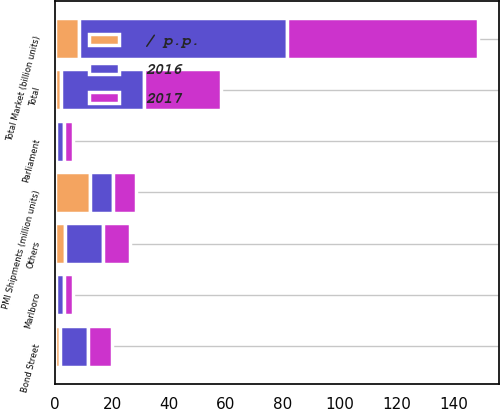<chart> <loc_0><loc_0><loc_500><loc_500><stacked_bar_chart><ecel><fcel>Total Market (billion units)<fcel>PMI Shipments (million units)<fcel>Marlboro<fcel>Parliament<fcel>Bond Street<fcel>Others<fcel>Total<nl><fcel>2017<fcel>67.1<fcel>8.2<fcel>3<fcel>3.2<fcel>8.4<fcel>9.6<fcel>27.3<nl><fcel>2016<fcel>73.1<fcel>8.2<fcel>3.1<fcel>2.9<fcel>10<fcel>13.2<fcel>29.2<nl><fcel>/ p.p.<fcel>8.2<fcel>12.1<fcel>0.1<fcel>0.3<fcel>1.6<fcel>3.6<fcel>1.9<nl></chart> 